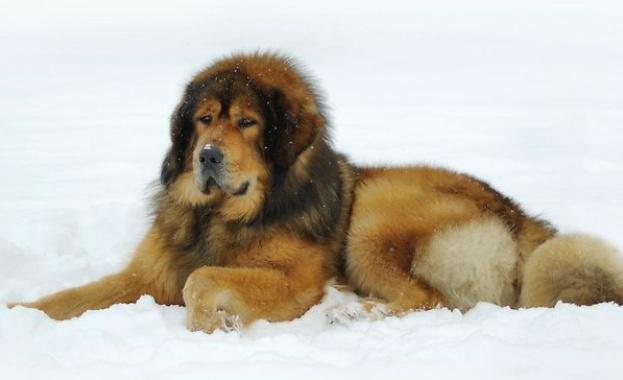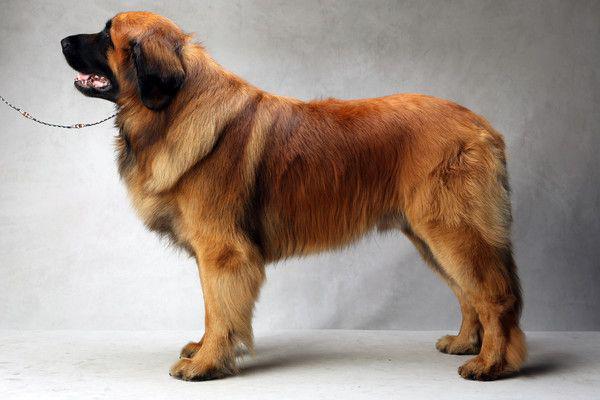The first image is the image on the left, the second image is the image on the right. Analyze the images presented: Is the assertion "One image shows a dog on snow-covered ground." valid? Answer yes or no. Yes. The first image is the image on the left, the second image is the image on the right. For the images shown, is this caption "A dog is on a ground filled with snow." true? Answer yes or no. Yes. 